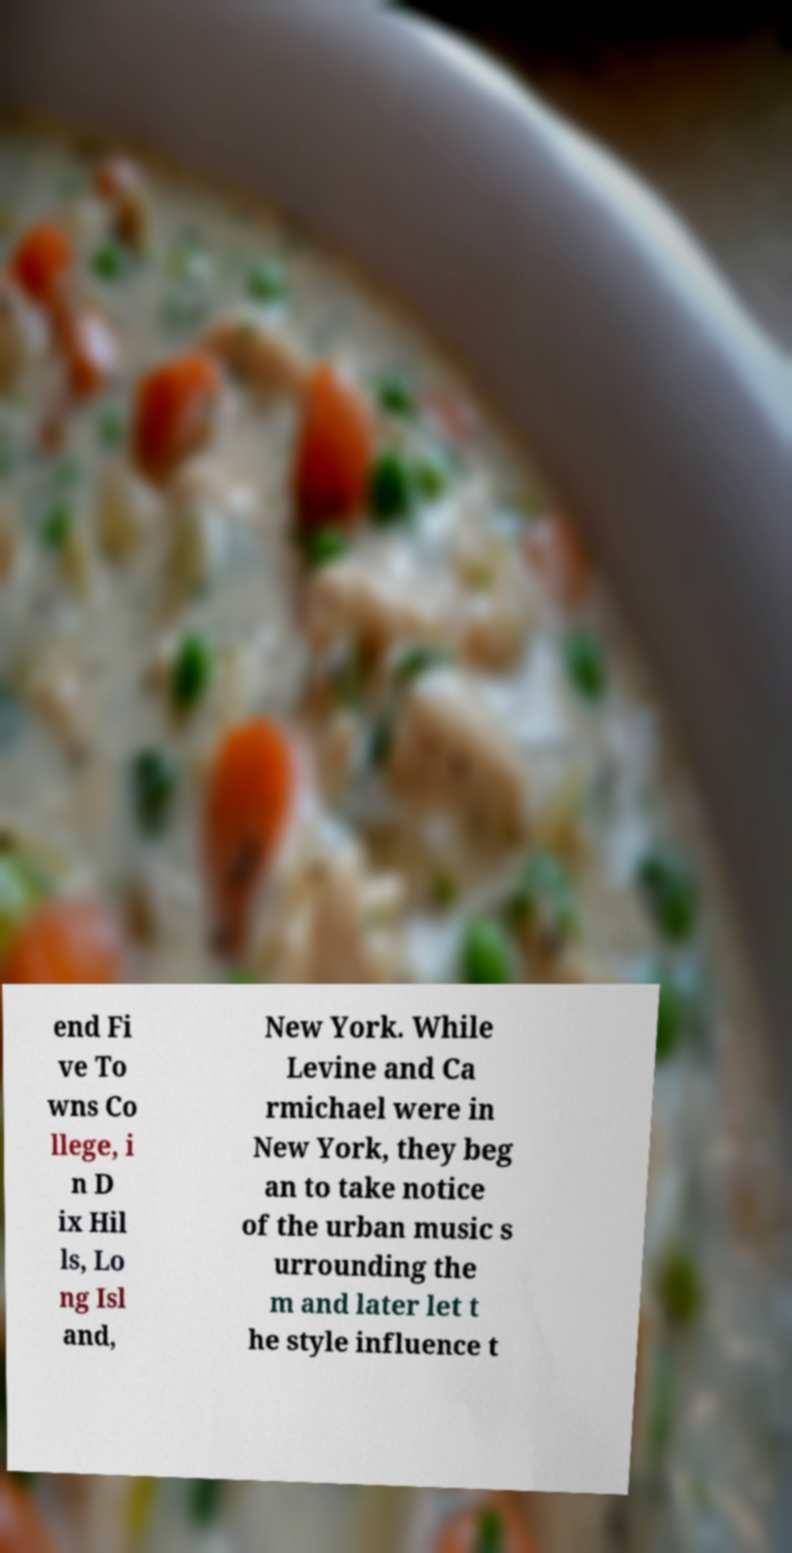For documentation purposes, I need the text within this image transcribed. Could you provide that? end Fi ve To wns Co llege, i n D ix Hil ls, Lo ng Isl and, New York. While Levine and Ca rmichael were in New York, they beg an to take notice of the urban music s urrounding the m and later let t he style influence t 